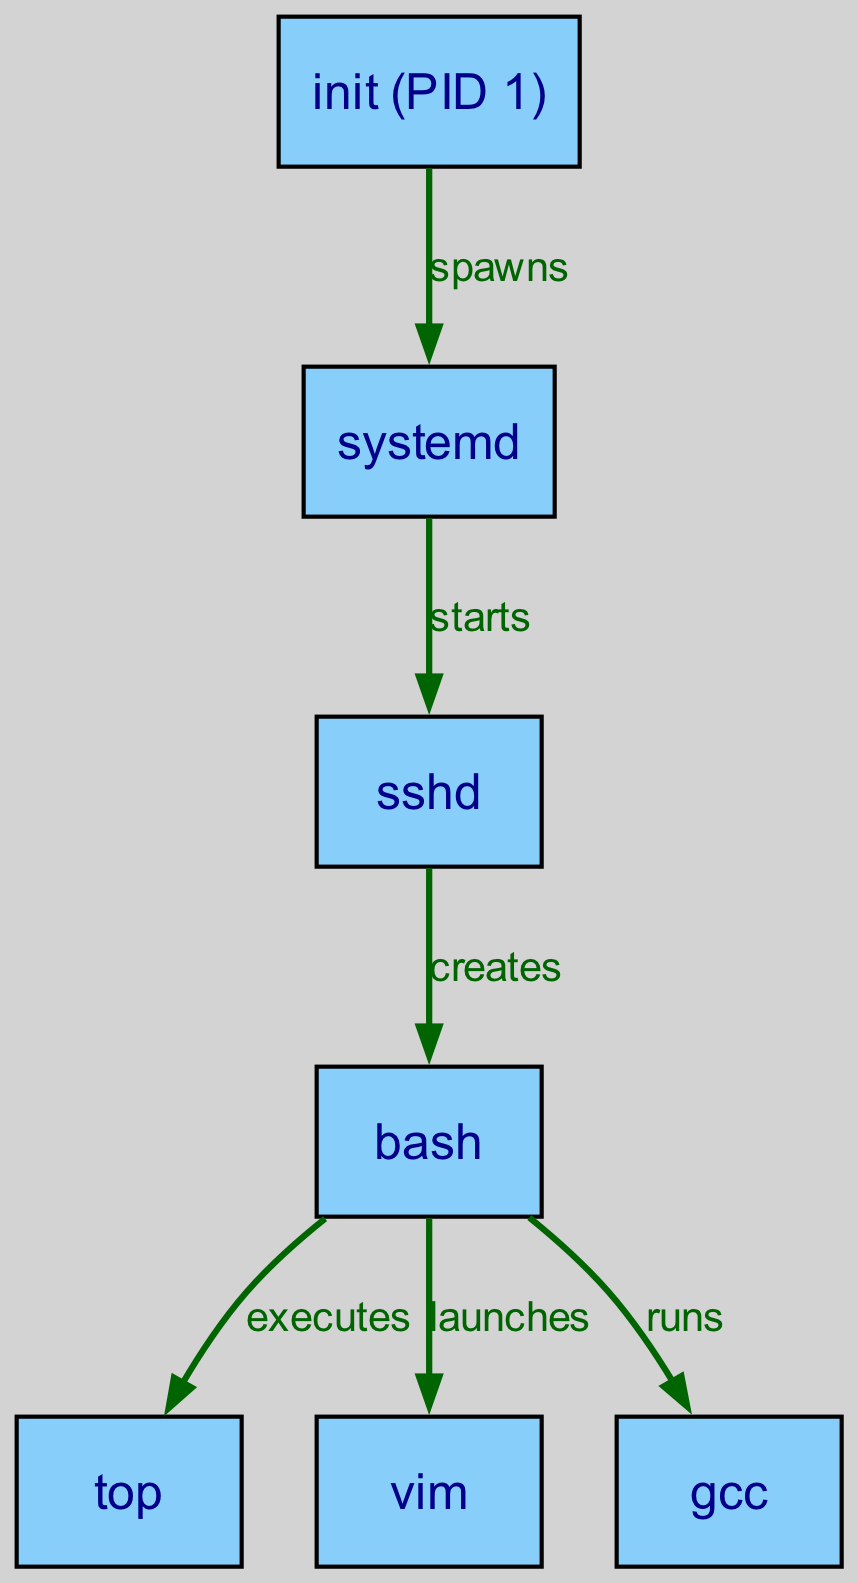What is the root of the process tree? The root of the process tree is the initial process that spawns all other processes in a UNIX system; in this diagram, it is labeled "init (PID 1)".
Answer: init (PID 1) How many nodes are there in the diagram? To determine the number of nodes, we count all the unique entities represented in the diagram, which are 7: init, systemd, sshd, bash, top, vim, and gcc.
Answer: 7 What process directly creates the bash shell? The label on the edge between the sshd node and the bash node indicates that sshd is responsible for creating the bash shell within this process tree.
Answer: sshd What process does bash execute? Looking at the edges emanating from the bash node, there are multiple processes executed by bash; specifically, it executes the top process as indicated by the directed edge labeled "executes".
Answer: top Which process is a child of systemd? There is a direct edge from systemd to sshd in the diagram, meaning that sshd is a child process spawned by systemd within this process hierarchy.
Answer: sshd What relationships does bash have with other processes? Analyzing the edges connected to the bash node, we see that bash executes top, launches vim, and runs gcc; this indicates multiple direct relationships where bash interacts with these processes.
Answer: executes, launches, runs Identify the process that has no children in the diagram. By examining the nodes, we see that the processes top, vim, and gcc have no outgoing edges, indicating that they do not create or invoke any other processes and are leaf nodes in this tree structure.
Answer: top, vim, gcc What is the process that was spawned directly from init? The edge from init to systemd indicates that systemd is the first-level child process spawned directly from the init process in the hierarchy.
Answer: systemd List all the processes launched by bash. The diagram shows directed edges from bash to three different processes: top, vim, and gcc; hence all these processes are launched by bash.
Answer: top, vim, gcc 